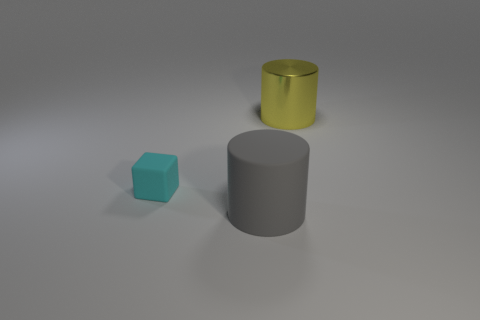Add 3 matte objects. How many objects exist? 6 Subtract all cubes. How many objects are left? 2 Subtract all gray objects. Subtract all red shiny cylinders. How many objects are left? 2 Add 3 gray matte things. How many gray matte things are left? 4 Add 2 large gray things. How many large gray things exist? 3 Subtract 0 yellow cubes. How many objects are left? 3 